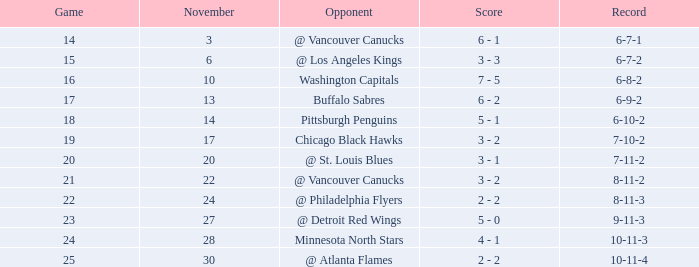What is the match occurring on november 27? 23.0. 